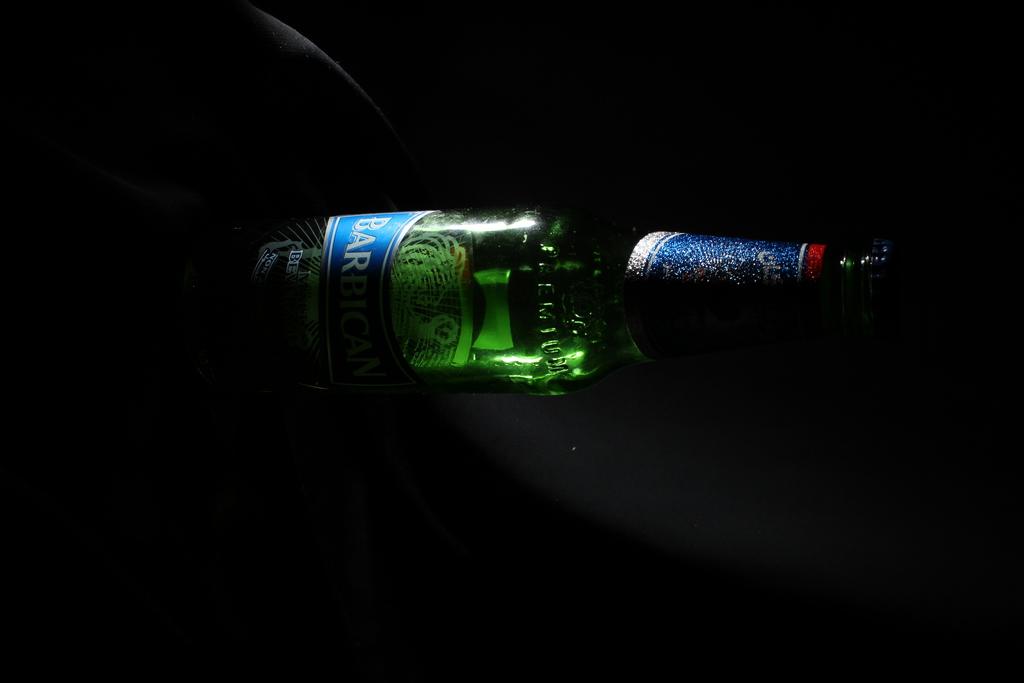What brand is this?
Give a very brief answer. Barbican. 